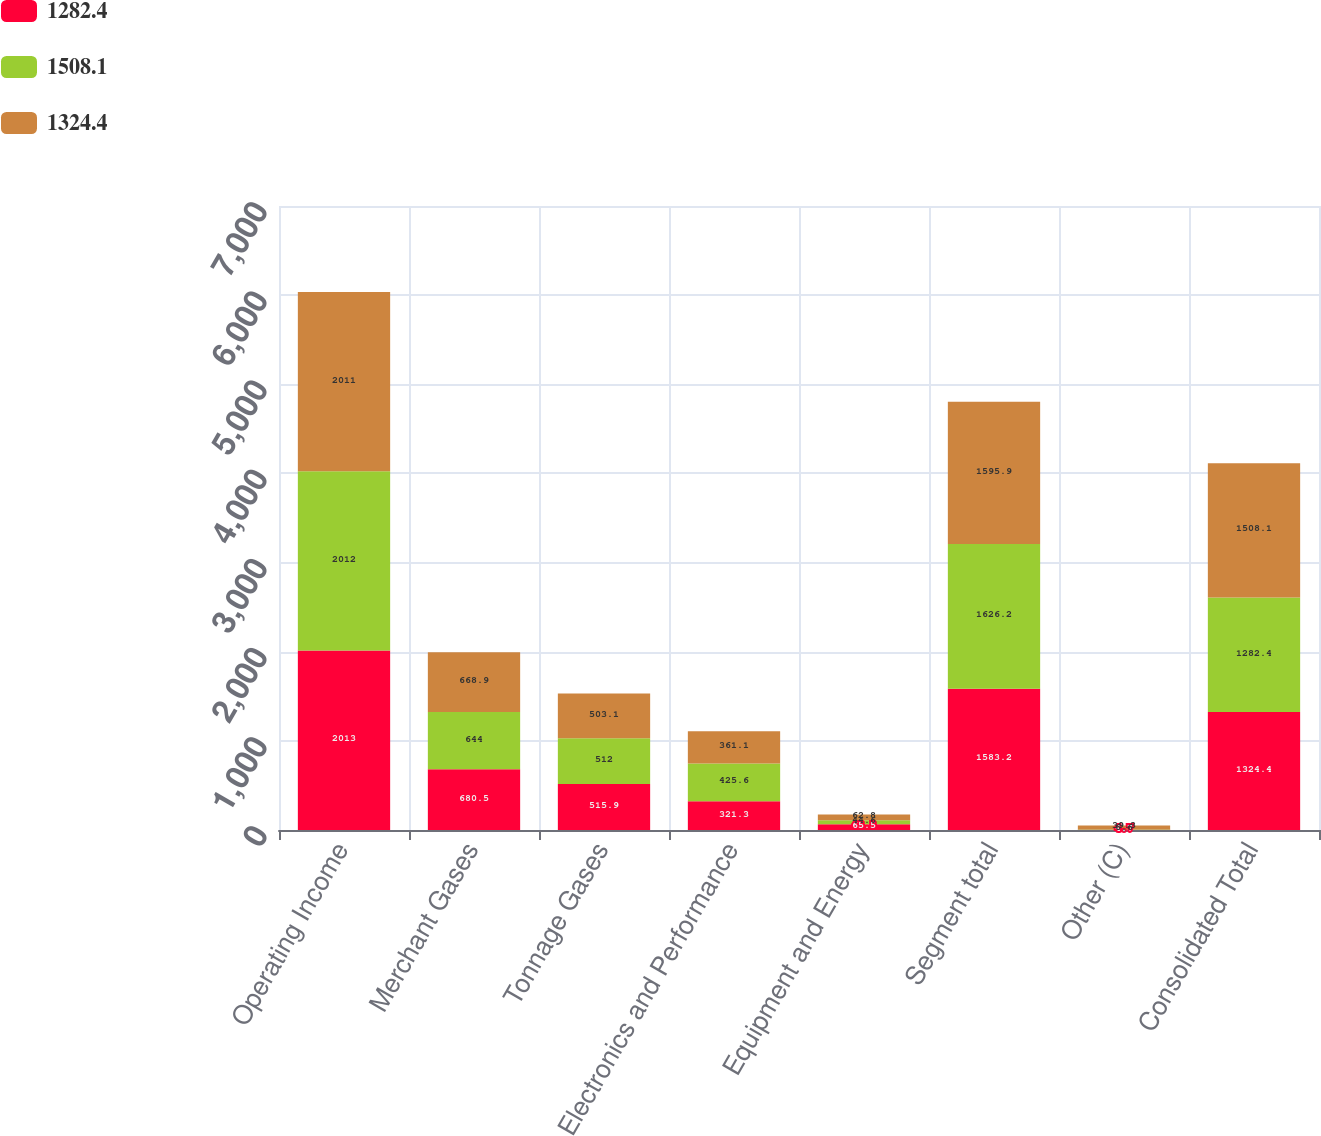Convert chart. <chart><loc_0><loc_0><loc_500><loc_500><stacked_bar_chart><ecel><fcel>Operating Income<fcel>Merchant Gases<fcel>Tonnage Gases<fcel>Electronics and Performance<fcel>Equipment and Energy<fcel>Segment total<fcel>Other (C)<fcel>Consolidated Total<nl><fcel>1282.4<fcel>2013<fcel>680.5<fcel>515.9<fcel>321.3<fcel>65.5<fcel>1583.2<fcel>4.7<fcel>1324.4<nl><fcel>1508.1<fcel>2012<fcel>644<fcel>512<fcel>425.6<fcel>44.6<fcel>1626.2<fcel>6.6<fcel>1282.4<nl><fcel>1324.4<fcel>2011<fcel>668.9<fcel>503.1<fcel>361.1<fcel>62.8<fcel>1595.9<fcel>39.3<fcel>1508.1<nl></chart> 